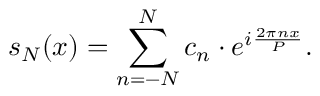Convert formula to latex. <formula><loc_0><loc_0><loc_500><loc_500>s _ { N } ( x ) = \sum _ { n = - N } ^ { N } c _ { n } \cdot e ^ { i { \frac { 2 \pi n x } { P } } } .</formula> 